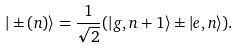<formula> <loc_0><loc_0><loc_500><loc_500>| \pm ( n ) \rangle = \frac { 1 } { \sqrt { 2 } } ( | g , n + 1 \rangle \pm | e , n \rangle ) .</formula> 